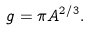Convert formula to latex. <formula><loc_0><loc_0><loc_500><loc_500>g = \pi A ^ { 2 / 3 } .</formula> 